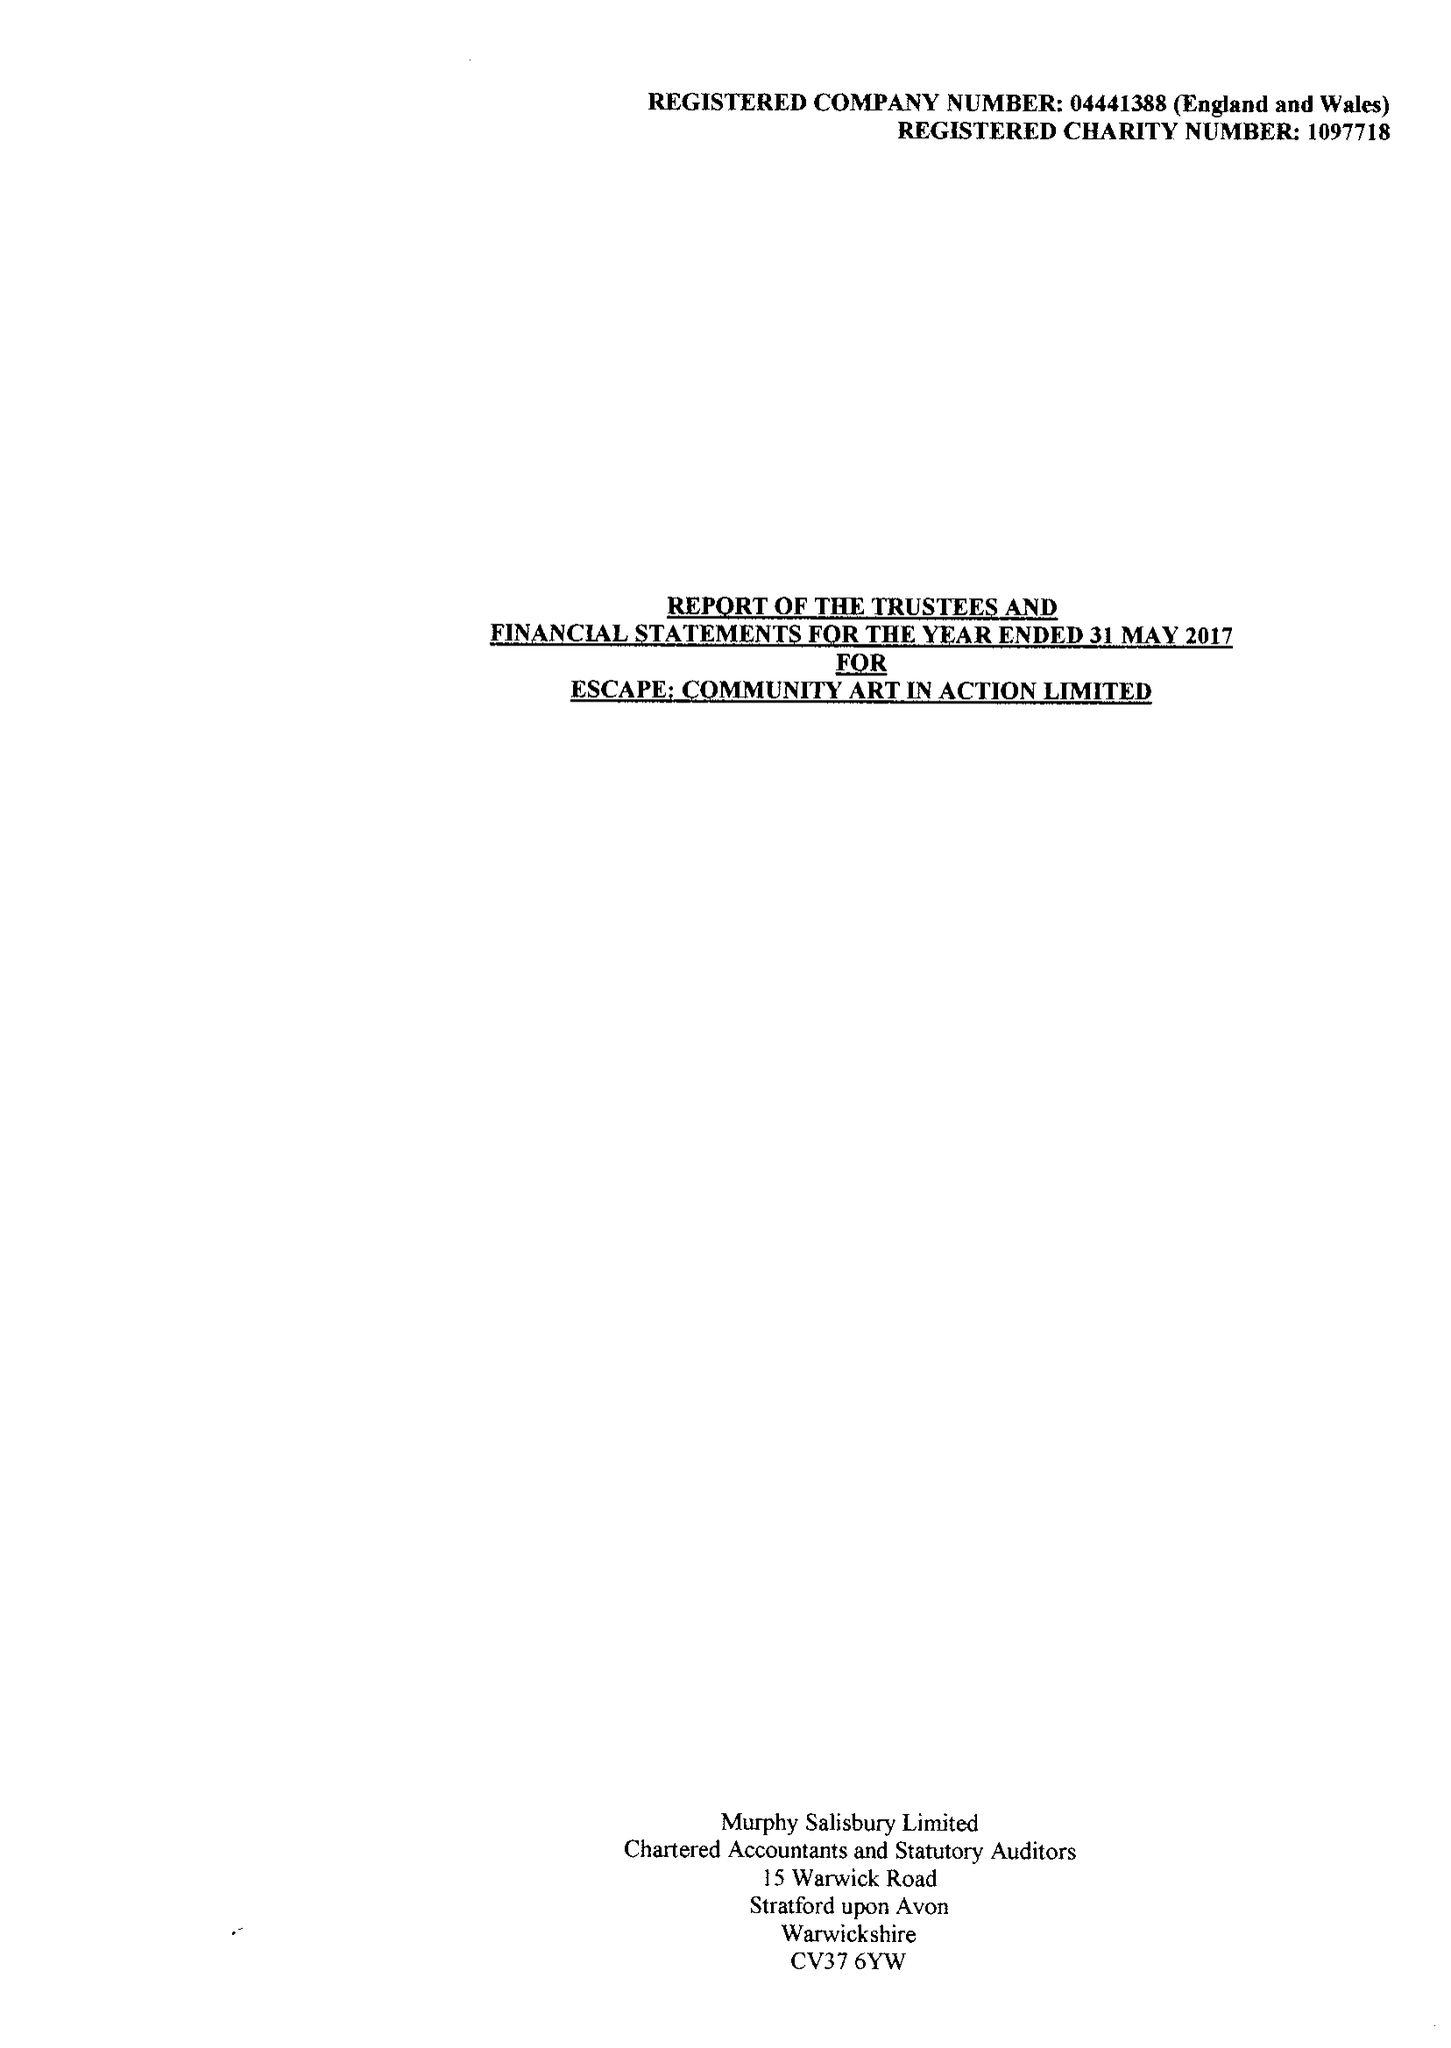What is the value for the charity_number?
Answer the question using a single word or phrase. 1097718 